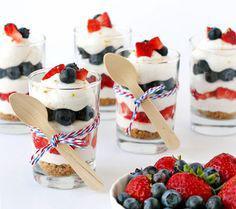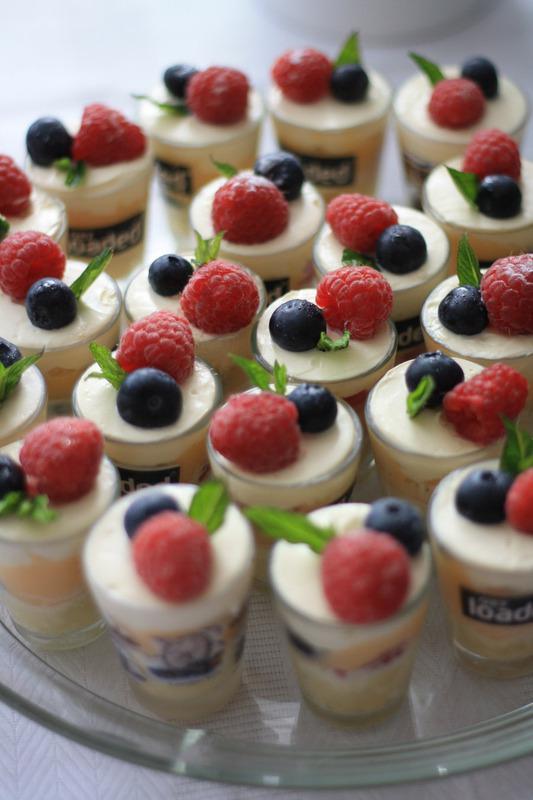The first image is the image on the left, the second image is the image on the right. Analyze the images presented: Is the assertion "the left image contains 2 layered dessert portions" valid? Answer yes or no. No. The first image is the image on the left, the second image is the image on the right. Given the left and right images, does the statement "There are treats in the right image that are topped with cherries, but none in the left image." hold true? Answer yes or no. No. 